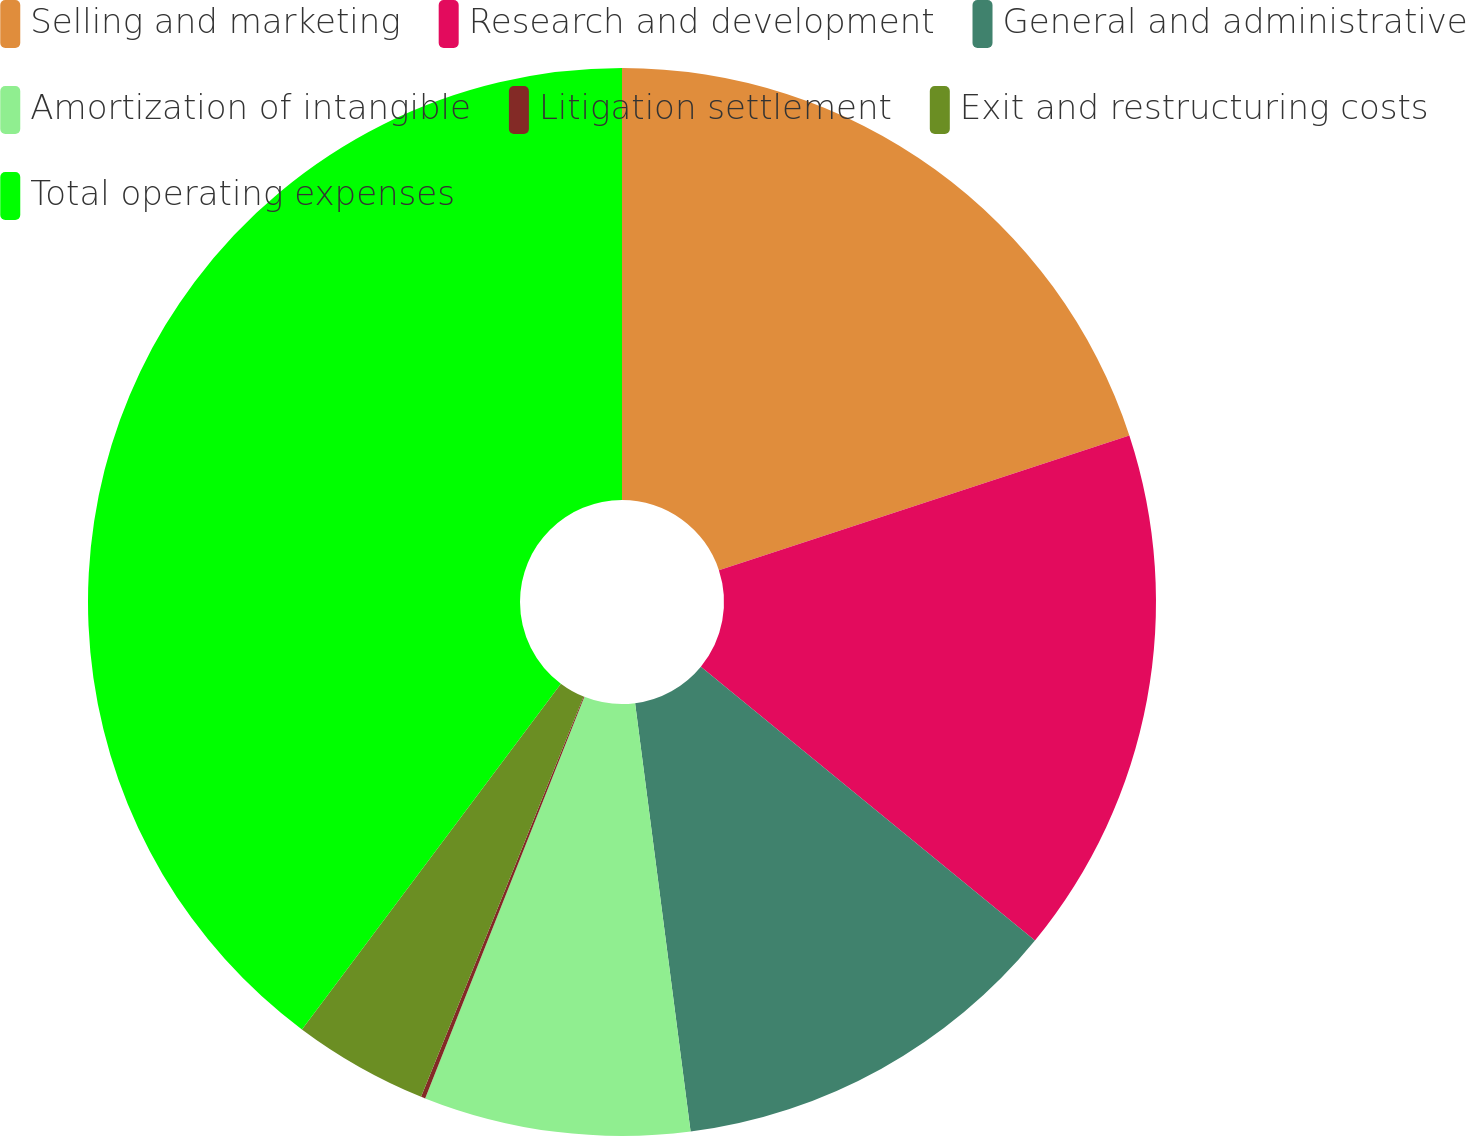Convert chart. <chart><loc_0><loc_0><loc_500><loc_500><pie_chart><fcel>Selling and marketing<fcel>Research and development<fcel>General and administrative<fcel>Amortization of intangible<fcel>Litigation settlement<fcel>Exit and restructuring costs<fcel>Total operating expenses<nl><fcel>19.95%<fcel>15.98%<fcel>12.02%<fcel>8.06%<fcel>0.13%<fcel>4.09%<fcel>39.77%<nl></chart> 